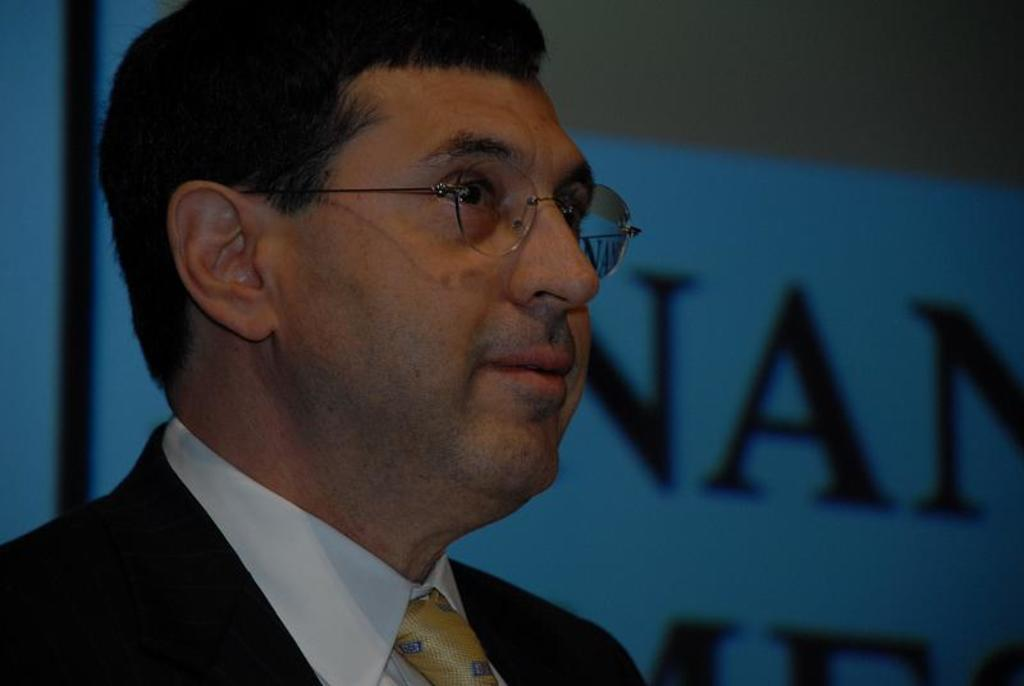Who is present in the image? There is a man in the image. What accessory is the man wearing? The man is wearing glasses (specs). What can be seen in the background of the image? There is a board with text in the background of the image. Is there a baby in the image? No, there is no baby present in the image. What type of trade is being conducted in the image? There is no trade being conducted in the image; it only features a man wearing glasses and a board with text in the background. 